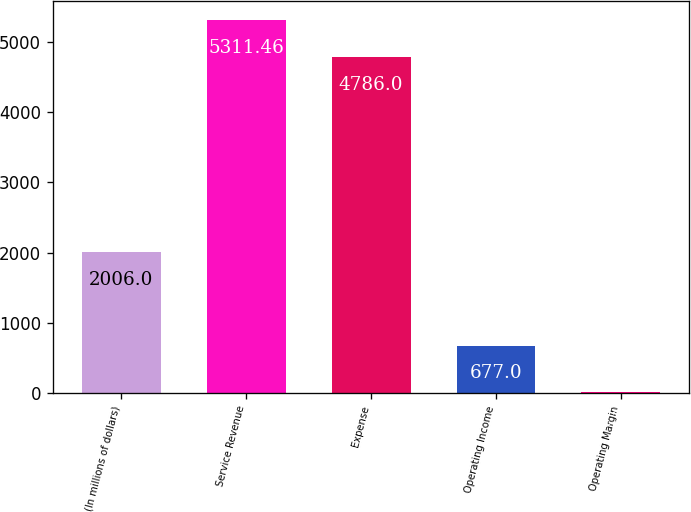Convert chart. <chart><loc_0><loc_0><loc_500><loc_500><bar_chart><fcel>(In millions of dollars)<fcel>Service Revenue<fcel>Expense<fcel>Operating Income<fcel>Operating Margin<nl><fcel>2006<fcel>5311.46<fcel>4786<fcel>677<fcel>12.4<nl></chart> 